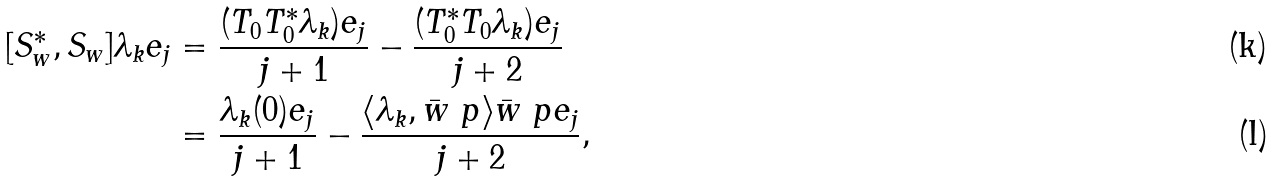Convert formula to latex. <formula><loc_0><loc_0><loc_500><loc_500>[ S _ { w } ^ { * } , S _ { w } ] \lambda _ { k } e _ { j } & = \frac { ( T _ { 0 } T _ { 0 } ^ { * } \lambda _ { k } ) e _ { j } } { j + 1 } - \frac { ( T _ { 0 } ^ { * } T _ { 0 } \lambda _ { k } ) e _ { j } } { j + 2 } \\ & = \frac { \lambda _ { k } ( 0 ) e _ { j } } { j + 1 } - \frac { \langle \lambda _ { k } , \bar { w } \ p \rangle \bar { w } \ p e _ { j } } { j + 2 } ,</formula> 